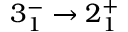<formula> <loc_0><loc_0><loc_500><loc_500>3 _ { 1 } ^ { - } \rightarrow 2 _ { 1 } ^ { + }</formula> 